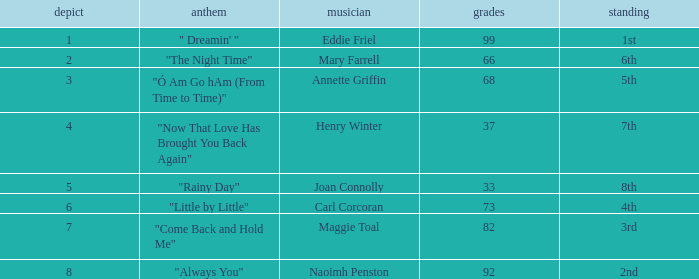What is the mean score when the position is 7th and the tie is below 4? None. 